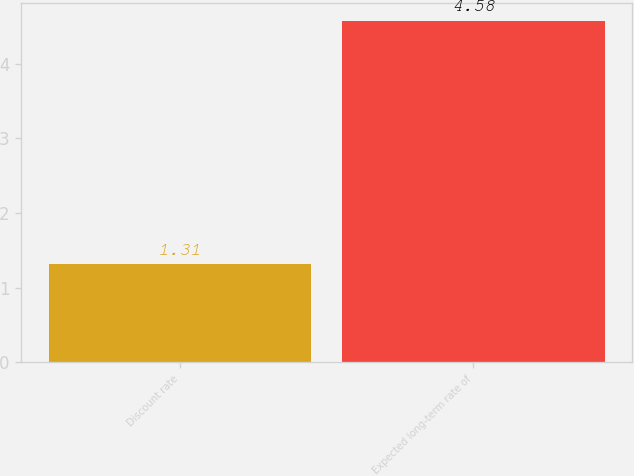<chart> <loc_0><loc_0><loc_500><loc_500><bar_chart><fcel>Discount rate<fcel>Expected long-term rate of<nl><fcel>1.31<fcel>4.58<nl></chart> 